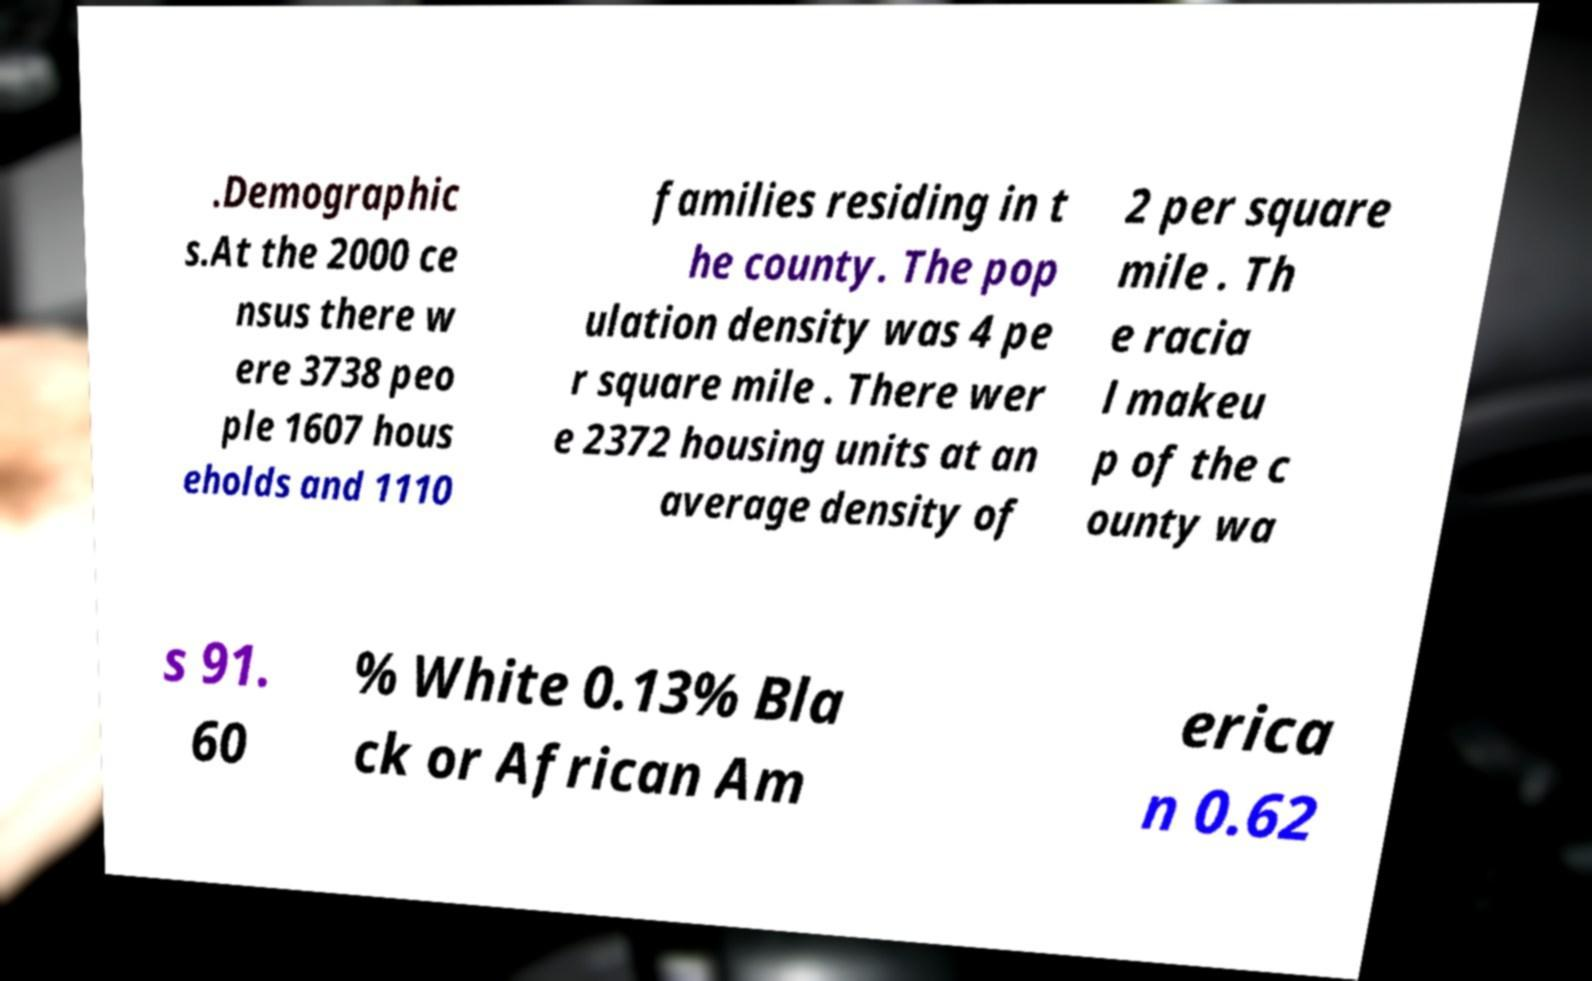Could you extract and type out the text from this image? .Demographic s.At the 2000 ce nsus there w ere 3738 peo ple 1607 hous eholds and 1110 families residing in t he county. The pop ulation density was 4 pe r square mile . There wer e 2372 housing units at an average density of 2 per square mile . Th e racia l makeu p of the c ounty wa s 91. 60 % White 0.13% Bla ck or African Am erica n 0.62 